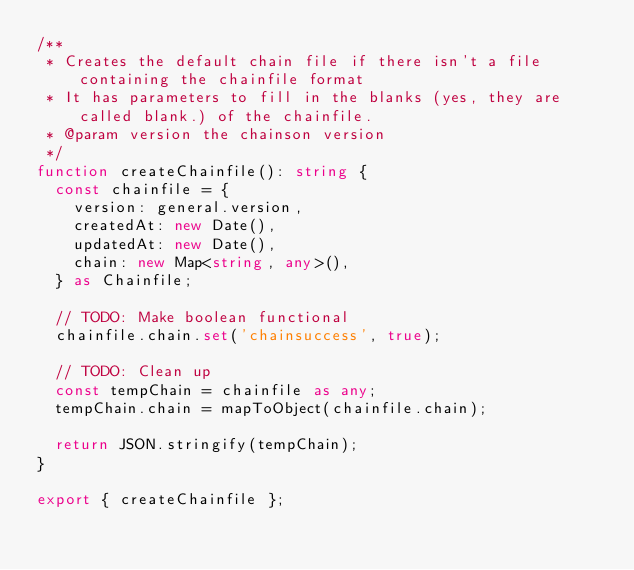<code> <loc_0><loc_0><loc_500><loc_500><_TypeScript_>/**
 * Creates the default chain file if there isn't a file containing the chainfile format
 * It has parameters to fill in the blanks (yes, they are called blank.) of the chainfile.
 * @param version the chainson version
 */
function createChainfile(): string {
  const chainfile = {
    version: general.version,
    createdAt: new Date(),
    updatedAt: new Date(),
    chain: new Map<string, any>(),
  } as Chainfile;

  // TODO: Make boolean functional
  chainfile.chain.set('chainsuccess', true);

  // TODO: Clean up
  const tempChain = chainfile as any;
  tempChain.chain = mapToObject(chainfile.chain);

  return JSON.stringify(tempChain);
}

export { createChainfile };
</code> 